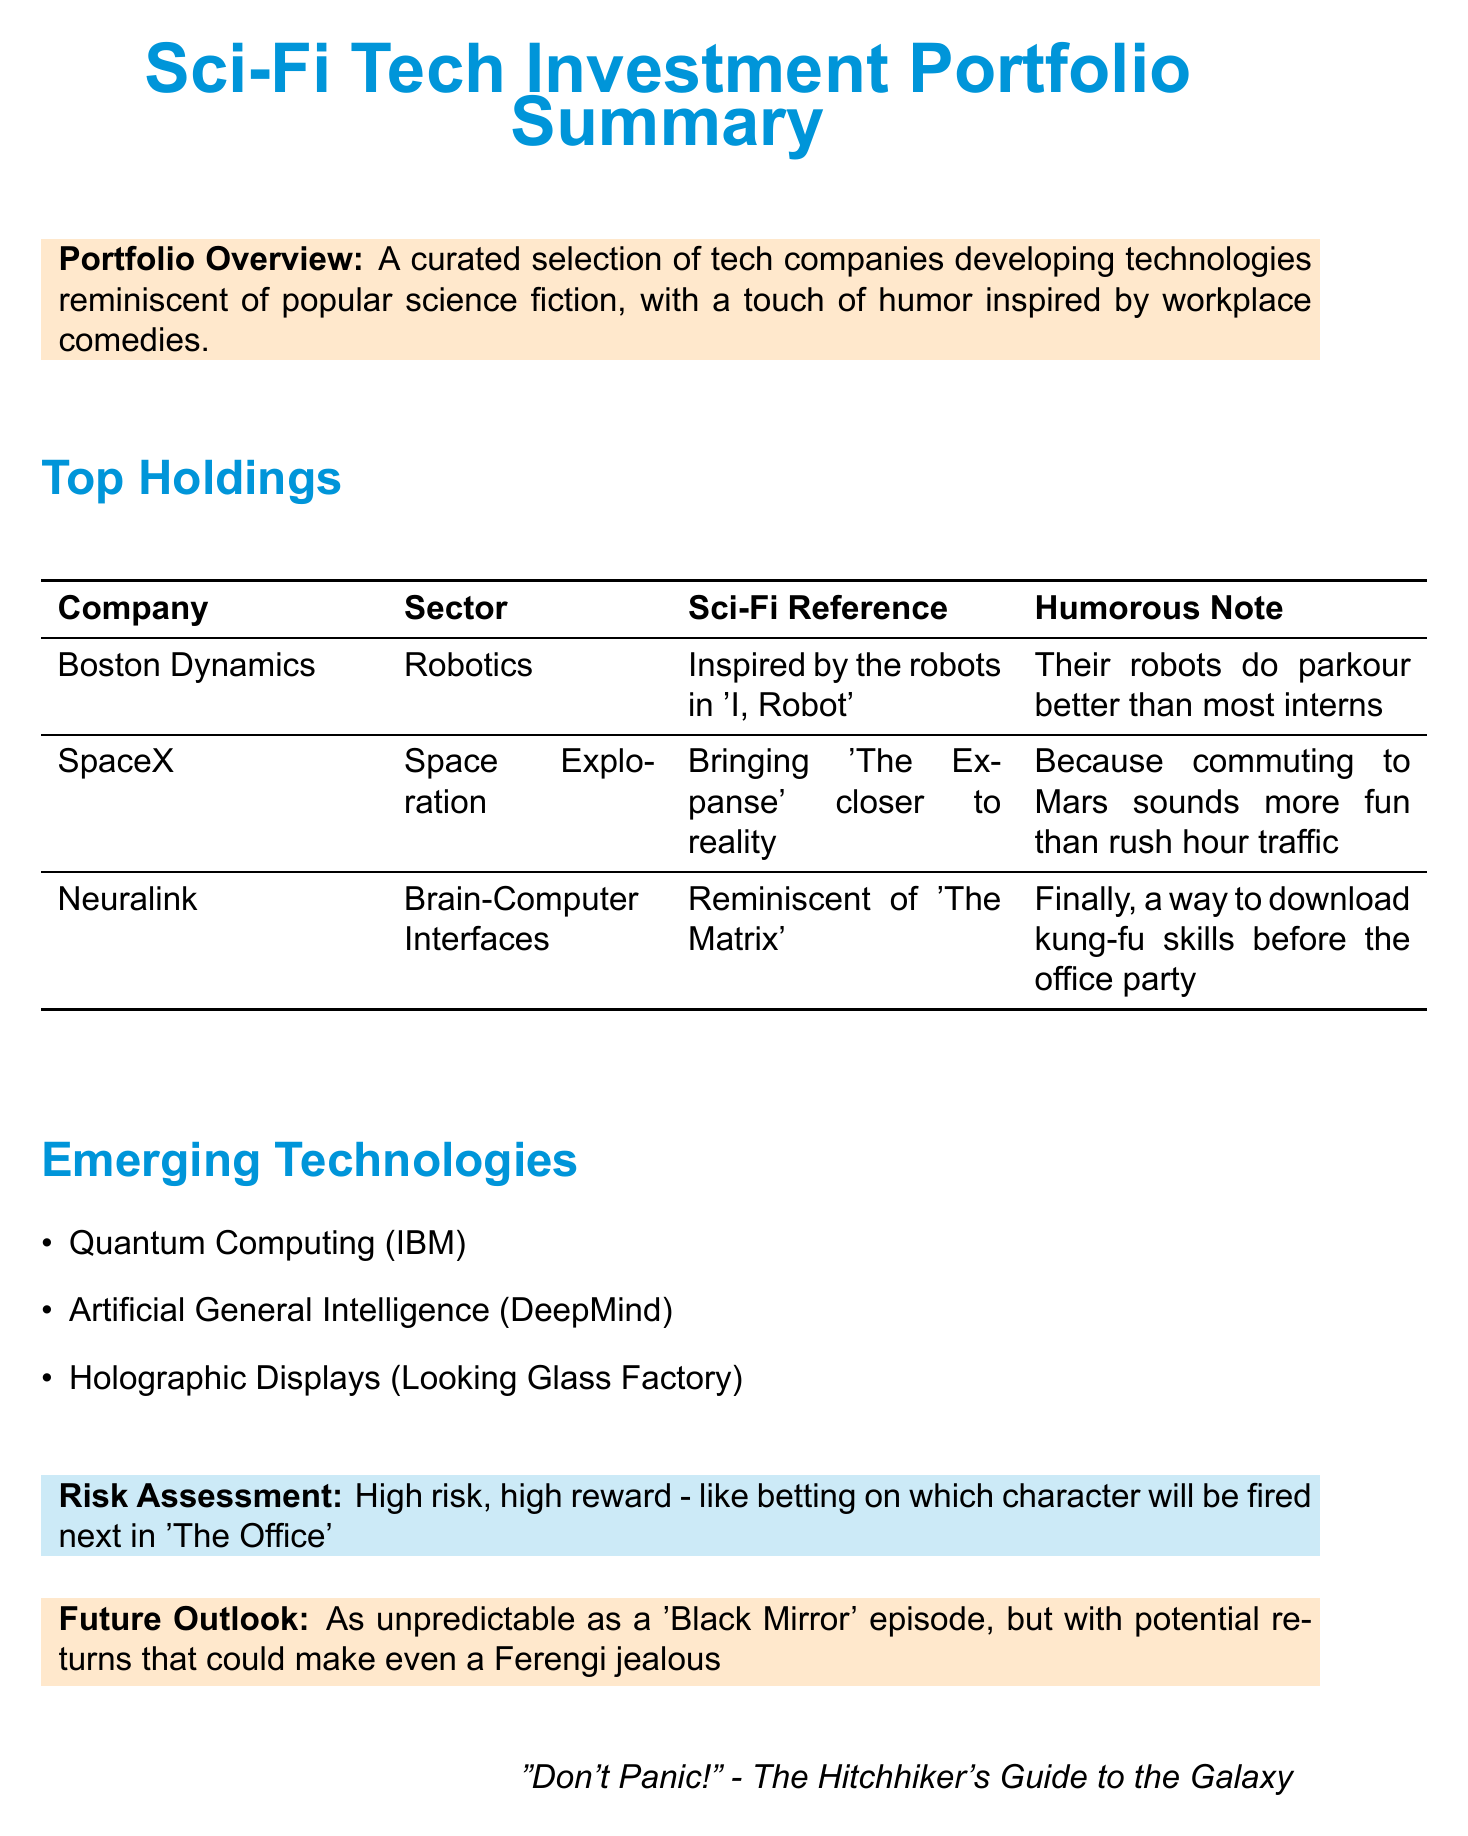What is the title of the report? The title of the report is clearly stated in the document.
Answer: Sci-Fi Tech Investment Portfolio Summary Which company is involved in robotics? The document lists top holdings, including companies and their respective sectors.
Answer: Boston Dynamics What sci-fi media inspired Neuralink? The document refers to specific sci-fi references made by the companies.
Answer: The Matrix What is the risk assessment description? The document provides a statement about the risk associated with the portfolio.
Answer: High risk, high reward - like betting on which character will be fired next in 'The Office' Which emerging technology is associated with IBM? The document lists emerging technologies and their corresponding companies.
Answer: Quantum Computing How many top holdings are listed in the document? A count of the companies mentioned in the top holdings section is requested.
Answer: Three What humorous note is given for SpaceX? The document includes humorous commentary related to each company's operations.
Answer: Because commuting to Mars sounds more fun than rush hour traffic What is the future outlook likened to? The document's future outlook section provides a comparative description.
Answer: As unpredictable as a 'Black Mirror' episode Who is quoted in the disclaimer? The quote section at the end of the document identifies the source of the quote.
Answer: The Hitchhiker's Guide to the Galaxy 